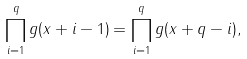Convert formula to latex. <formula><loc_0><loc_0><loc_500><loc_500>\prod _ { i = 1 } ^ { q } g ( x + i - 1 ) = \prod _ { i = 1 } ^ { q } g ( x + q - i ) ,</formula> 